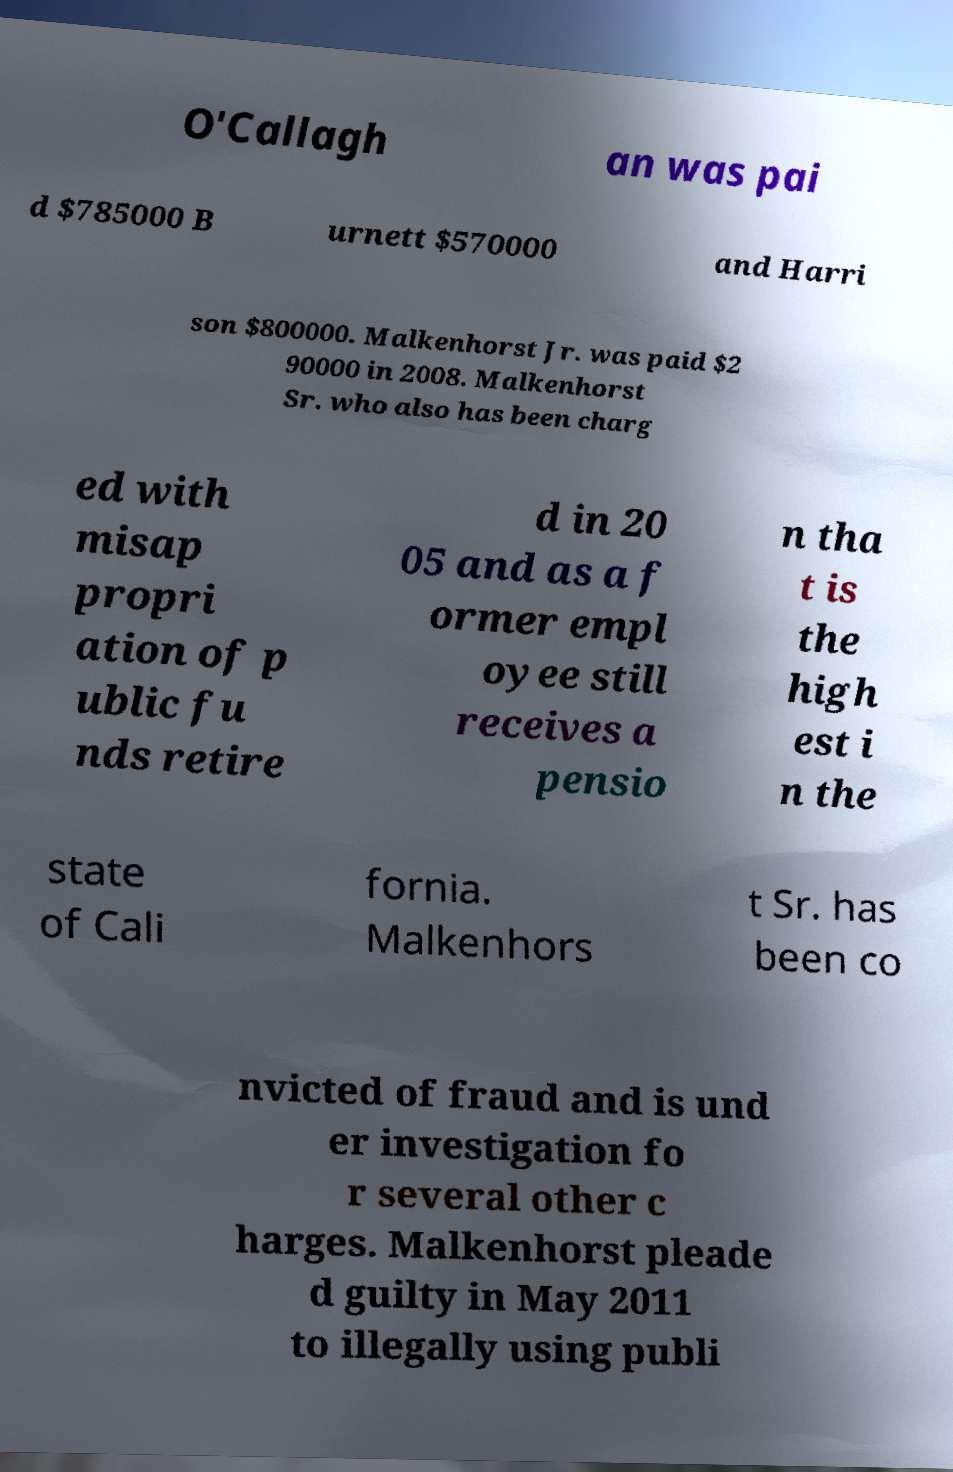There's text embedded in this image that I need extracted. Can you transcribe it verbatim? O'Callagh an was pai d $785000 B urnett $570000 and Harri son $800000. Malkenhorst Jr. was paid $2 90000 in 2008. Malkenhorst Sr. who also has been charg ed with misap propri ation of p ublic fu nds retire d in 20 05 and as a f ormer empl oyee still receives a pensio n tha t is the high est i n the state of Cali fornia. Malkenhors t Sr. has been co nvicted of fraud and is und er investigation fo r several other c harges. Malkenhorst pleade d guilty in May 2011 to illegally using publi 